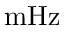<formula> <loc_0><loc_0><loc_500><loc_500>m H z</formula> 